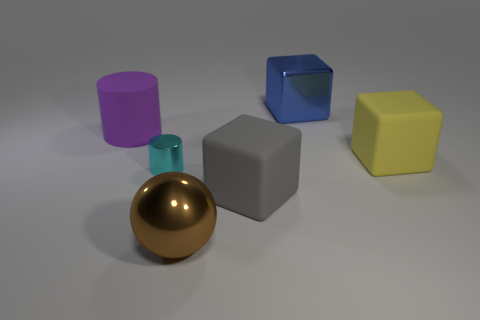How many cylinders have the same material as the gray block? Upon examining the image, it appears that there is one cylinder with a reflective surface similar to the gray block. This cylinder has a metallic sheen which matches the gray block's material characteristic. Therefore, there is one cylinder sharing the same material as the gray block. 